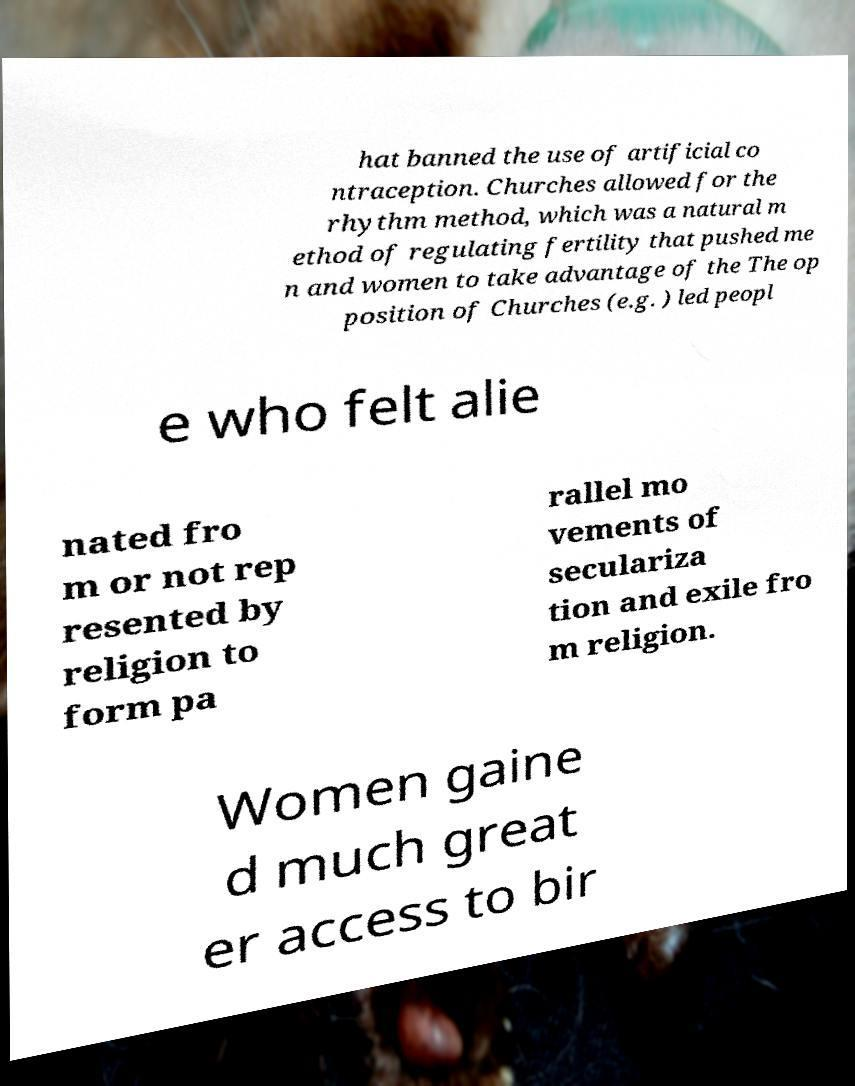Could you assist in decoding the text presented in this image and type it out clearly? hat banned the use of artificial co ntraception. Churches allowed for the rhythm method, which was a natural m ethod of regulating fertility that pushed me n and women to take advantage of the The op position of Churches (e.g. ) led peopl e who felt alie nated fro m or not rep resented by religion to form pa rallel mo vements of seculariza tion and exile fro m religion. Women gaine d much great er access to bir 